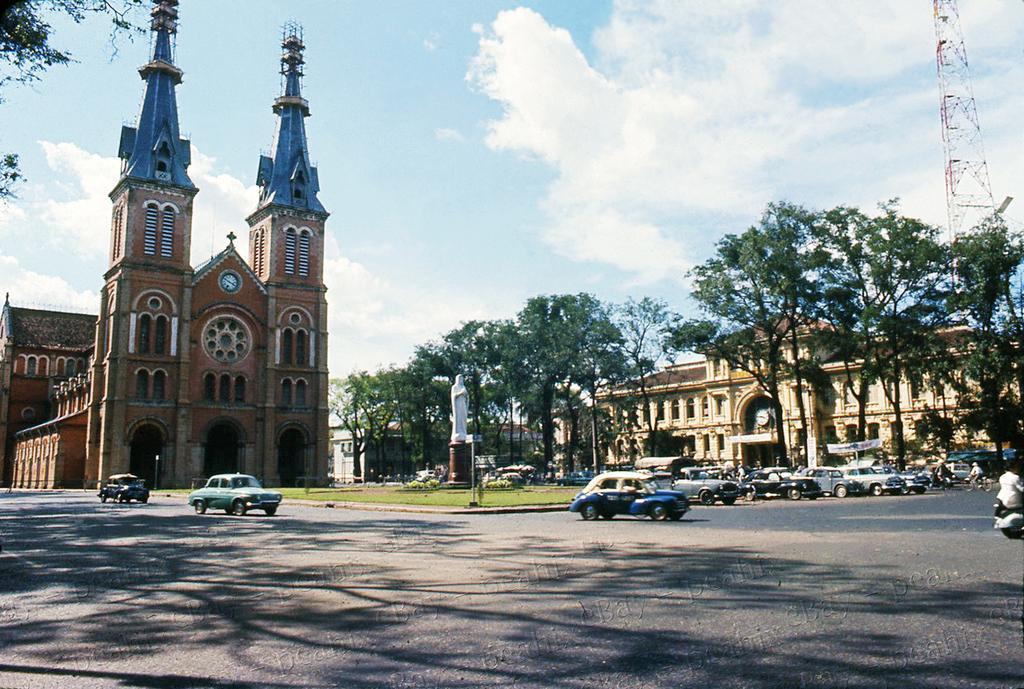Please provide a concise description of this image. In this picture we can see the buildings, church and trees. On the right we can see a man who is riding a scooter. Beside him we can see many cars which are parked near to the park. In the center we can see the statue. At the top we can see the sky and clouds. In the top right corner there is a tower near to the building. 